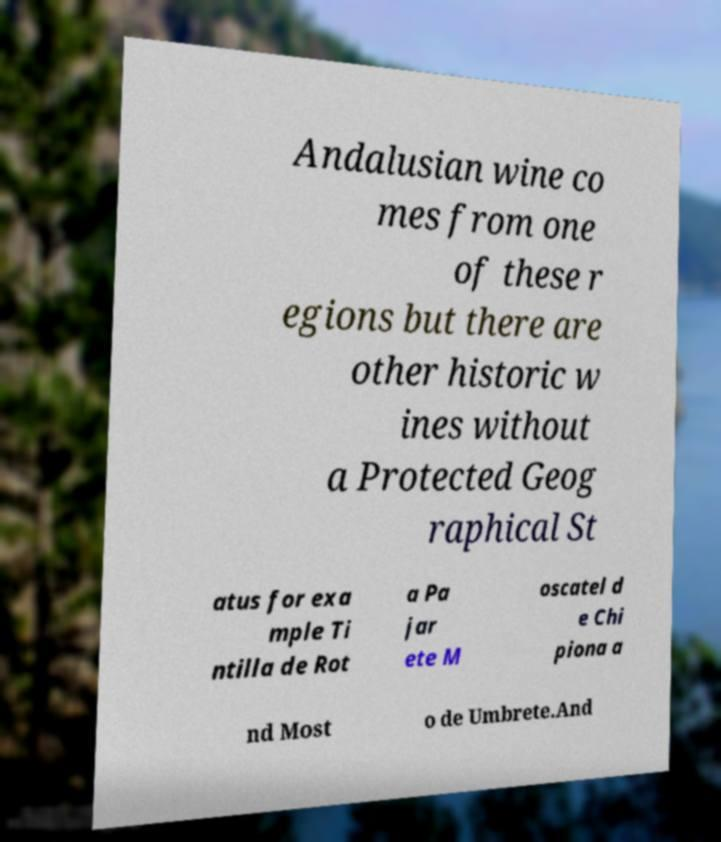Could you assist in decoding the text presented in this image and type it out clearly? Andalusian wine co mes from one of these r egions but there are other historic w ines without a Protected Geog raphical St atus for exa mple Ti ntilla de Rot a Pa jar ete M oscatel d e Chi piona a nd Most o de Umbrete.And 